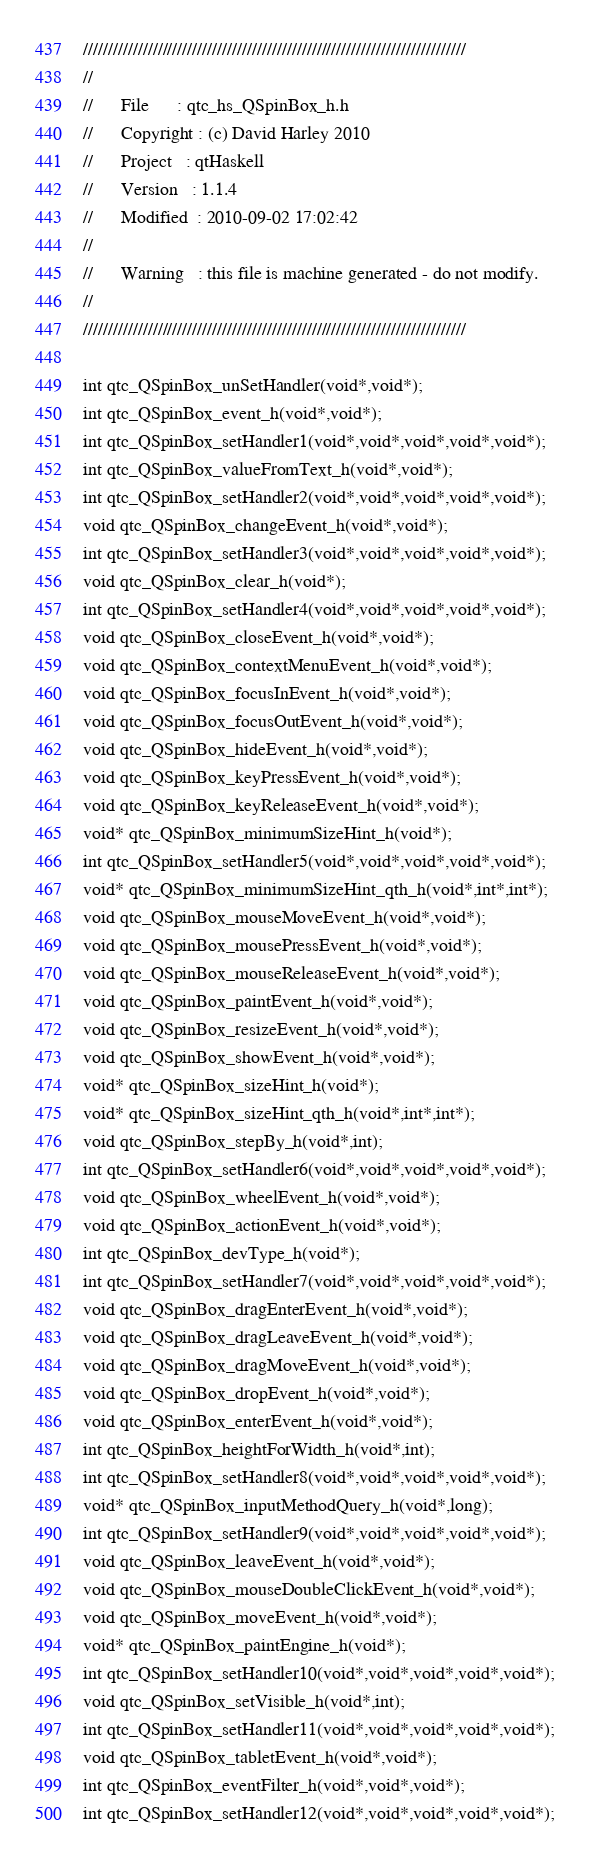Convert code to text. <code><loc_0><loc_0><loc_500><loc_500><_C_>/////////////////////////////////////////////////////////////////////////////
//      
//      File      : qtc_hs_QSpinBox_h.h
//      Copyright : (c) David Harley 2010
//      Project   : qtHaskell
//      Version   : 1.1.4
//      Modified  : 2010-09-02 17:02:42
//      
//      Warning   : this file is machine generated - do not modify.
//      
/////////////////////////////////////////////////////////////////////////////

int qtc_QSpinBox_unSetHandler(void*,void*);
int qtc_QSpinBox_event_h(void*,void*);
int qtc_QSpinBox_setHandler1(void*,void*,void*,void*,void*);
int qtc_QSpinBox_valueFromText_h(void*,void*);
int qtc_QSpinBox_setHandler2(void*,void*,void*,void*,void*);
void qtc_QSpinBox_changeEvent_h(void*,void*);
int qtc_QSpinBox_setHandler3(void*,void*,void*,void*,void*);
void qtc_QSpinBox_clear_h(void*);
int qtc_QSpinBox_setHandler4(void*,void*,void*,void*,void*);
void qtc_QSpinBox_closeEvent_h(void*,void*);
void qtc_QSpinBox_contextMenuEvent_h(void*,void*);
void qtc_QSpinBox_focusInEvent_h(void*,void*);
void qtc_QSpinBox_focusOutEvent_h(void*,void*);
void qtc_QSpinBox_hideEvent_h(void*,void*);
void qtc_QSpinBox_keyPressEvent_h(void*,void*);
void qtc_QSpinBox_keyReleaseEvent_h(void*,void*);
void* qtc_QSpinBox_minimumSizeHint_h(void*);
int qtc_QSpinBox_setHandler5(void*,void*,void*,void*,void*);
void* qtc_QSpinBox_minimumSizeHint_qth_h(void*,int*,int*);
void qtc_QSpinBox_mouseMoveEvent_h(void*,void*);
void qtc_QSpinBox_mousePressEvent_h(void*,void*);
void qtc_QSpinBox_mouseReleaseEvent_h(void*,void*);
void qtc_QSpinBox_paintEvent_h(void*,void*);
void qtc_QSpinBox_resizeEvent_h(void*,void*);
void qtc_QSpinBox_showEvent_h(void*,void*);
void* qtc_QSpinBox_sizeHint_h(void*);
void* qtc_QSpinBox_sizeHint_qth_h(void*,int*,int*);
void qtc_QSpinBox_stepBy_h(void*,int);
int qtc_QSpinBox_setHandler6(void*,void*,void*,void*,void*);
void qtc_QSpinBox_wheelEvent_h(void*,void*);
void qtc_QSpinBox_actionEvent_h(void*,void*);
int qtc_QSpinBox_devType_h(void*);
int qtc_QSpinBox_setHandler7(void*,void*,void*,void*,void*);
void qtc_QSpinBox_dragEnterEvent_h(void*,void*);
void qtc_QSpinBox_dragLeaveEvent_h(void*,void*);
void qtc_QSpinBox_dragMoveEvent_h(void*,void*);
void qtc_QSpinBox_dropEvent_h(void*,void*);
void qtc_QSpinBox_enterEvent_h(void*,void*);
int qtc_QSpinBox_heightForWidth_h(void*,int);
int qtc_QSpinBox_setHandler8(void*,void*,void*,void*,void*);
void* qtc_QSpinBox_inputMethodQuery_h(void*,long);
int qtc_QSpinBox_setHandler9(void*,void*,void*,void*,void*);
void qtc_QSpinBox_leaveEvent_h(void*,void*);
void qtc_QSpinBox_mouseDoubleClickEvent_h(void*,void*);
void qtc_QSpinBox_moveEvent_h(void*,void*);
void* qtc_QSpinBox_paintEngine_h(void*);
int qtc_QSpinBox_setHandler10(void*,void*,void*,void*,void*);
void qtc_QSpinBox_setVisible_h(void*,int);
int qtc_QSpinBox_setHandler11(void*,void*,void*,void*,void*);
void qtc_QSpinBox_tabletEvent_h(void*,void*);
int qtc_QSpinBox_eventFilter_h(void*,void*,void*);
int qtc_QSpinBox_setHandler12(void*,void*,void*,void*,void*);
</code> 